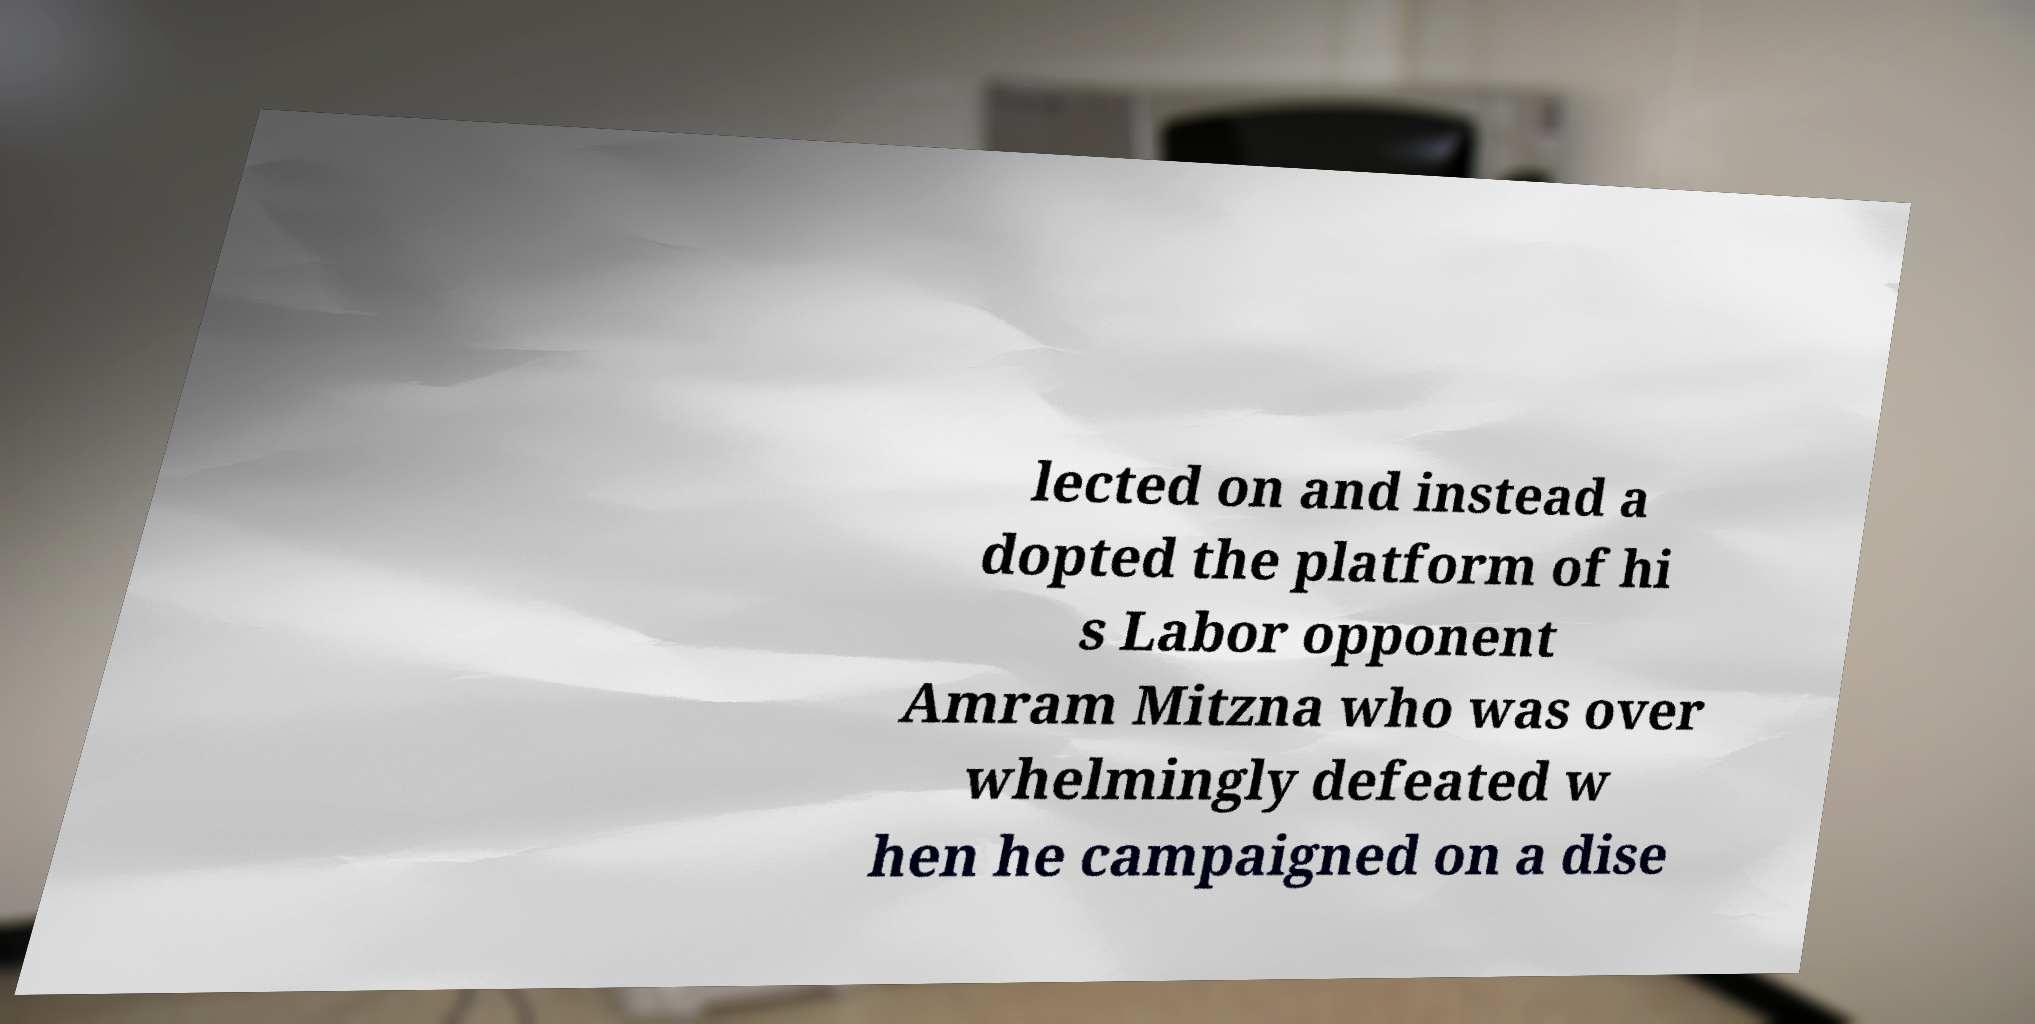What messages or text are displayed in this image? I need them in a readable, typed format. lected on and instead a dopted the platform of hi s Labor opponent Amram Mitzna who was over whelmingly defeated w hen he campaigned on a dise 